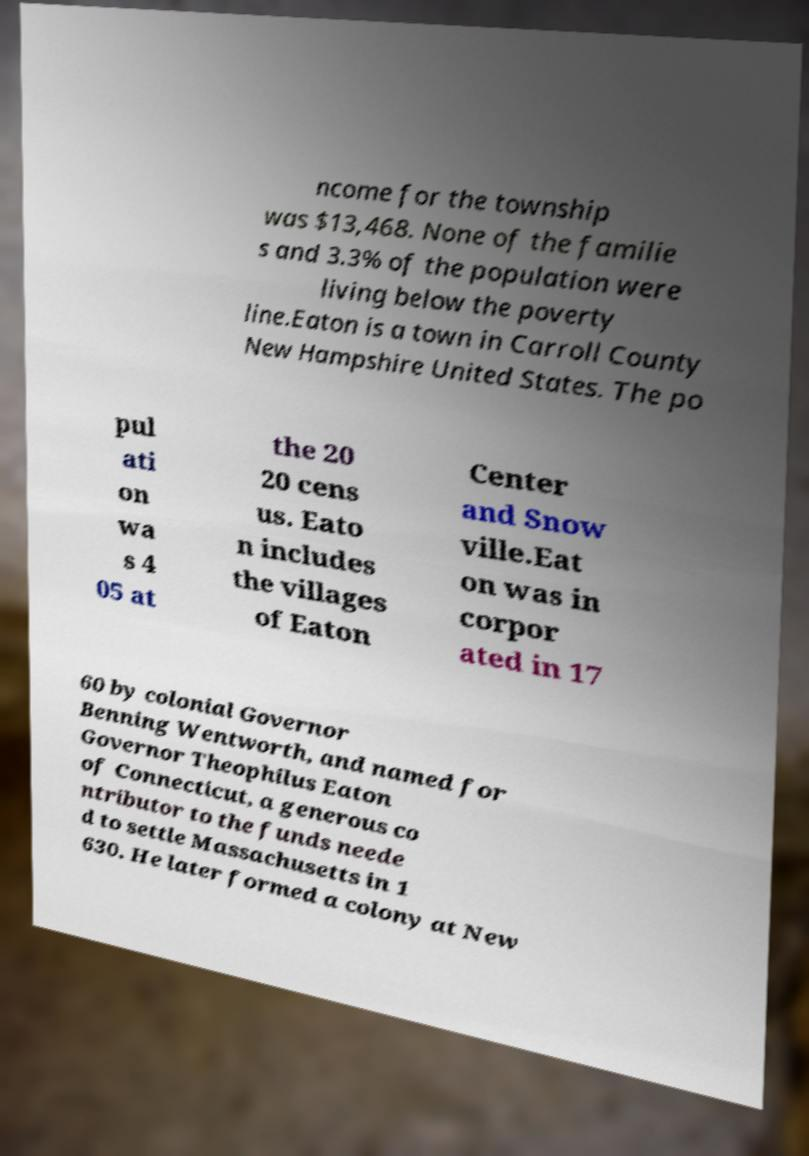Could you extract and type out the text from this image? ncome for the township was $13,468. None of the familie s and 3.3% of the population were living below the poverty line.Eaton is a town in Carroll County New Hampshire United States. The po pul ati on wa s 4 05 at the 20 20 cens us. Eato n includes the villages of Eaton Center and Snow ville.Eat on was in corpor ated in 17 60 by colonial Governor Benning Wentworth, and named for Governor Theophilus Eaton of Connecticut, a generous co ntributor to the funds neede d to settle Massachusetts in 1 630. He later formed a colony at New 